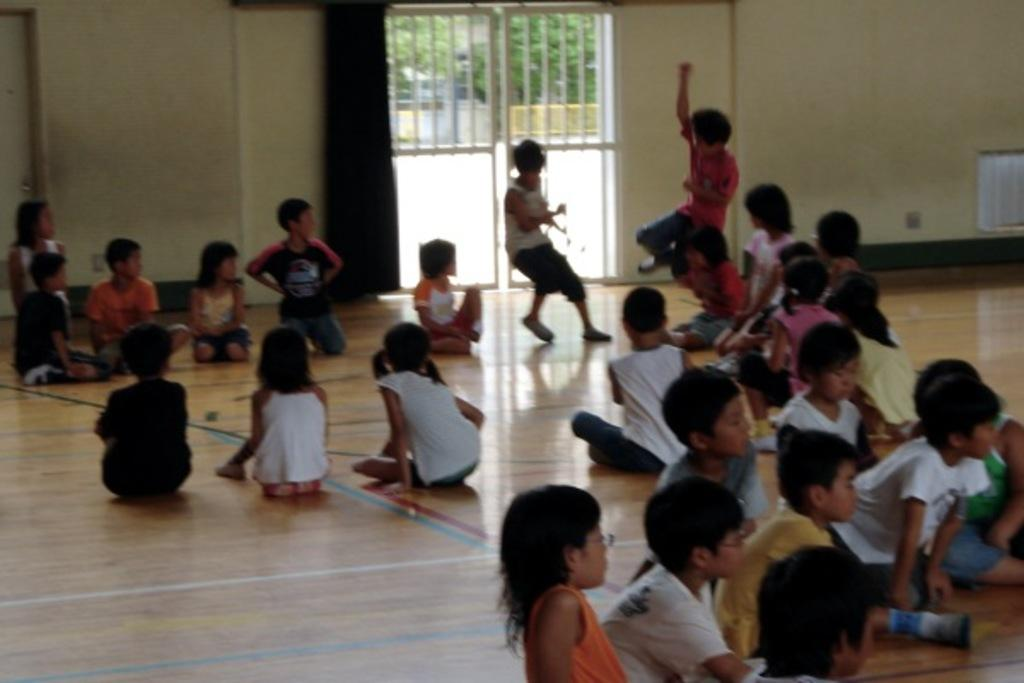How many kids are in the image? There are kids in the image, but the exact number is not specified. What are the kids doing in the image? Some of the kids are sitting, while others are standing. What can be seen in the background of the image? There is a fence door in the background of the image. What type of plantation can be seen in the image? There is no plantation present in the image. What kind of punishment is being administered to the kids in the image? There is no indication of punishment in the image; the kids are simply sitting and standing. 